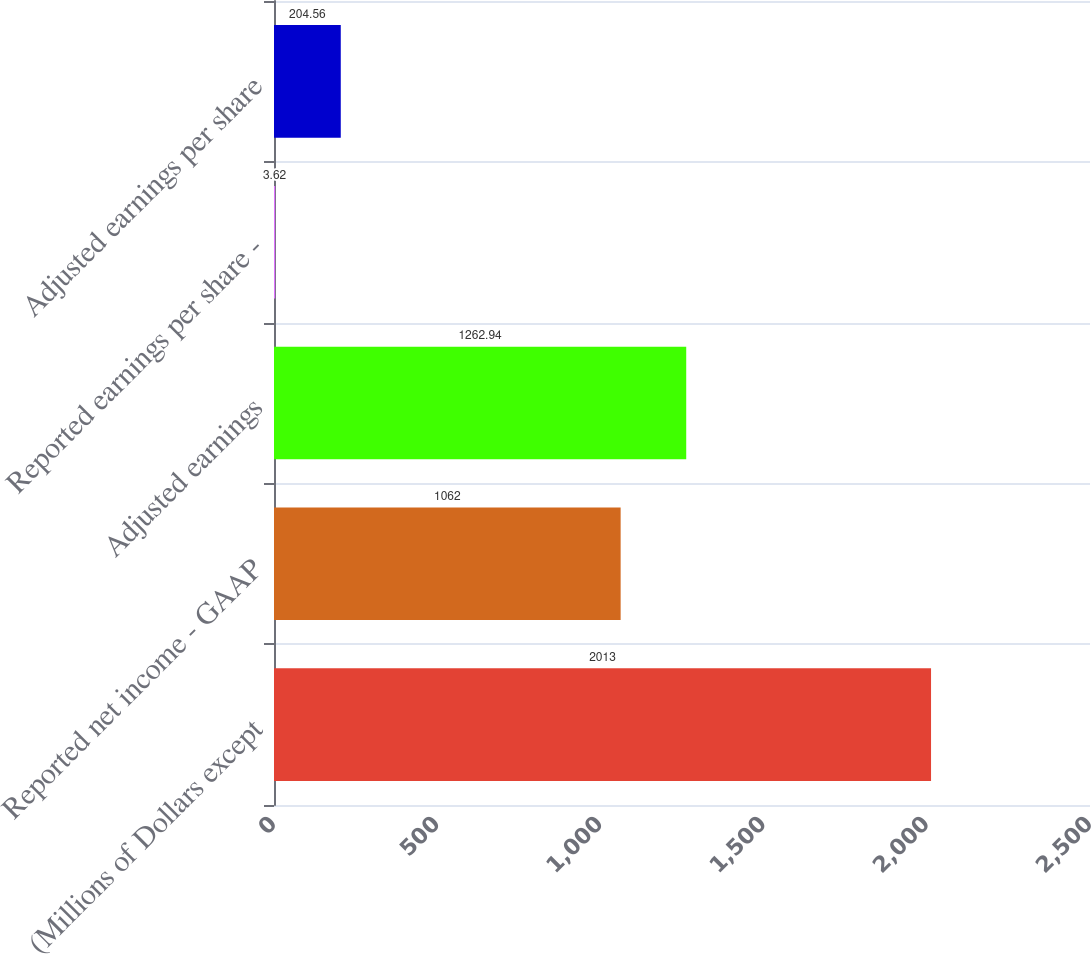<chart> <loc_0><loc_0><loc_500><loc_500><bar_chart><fcel>(Millions of Dollars except<fcel>Reported net income - GAAP<fcel>Adjusted earnings<fcel>Reported earnings per share -<fcel>Adjusted earnings per share<nl><fcel>2013<fcel>1062<fcel>1262.94<fcel>3.62<fcel>204.56<nl></chart> 